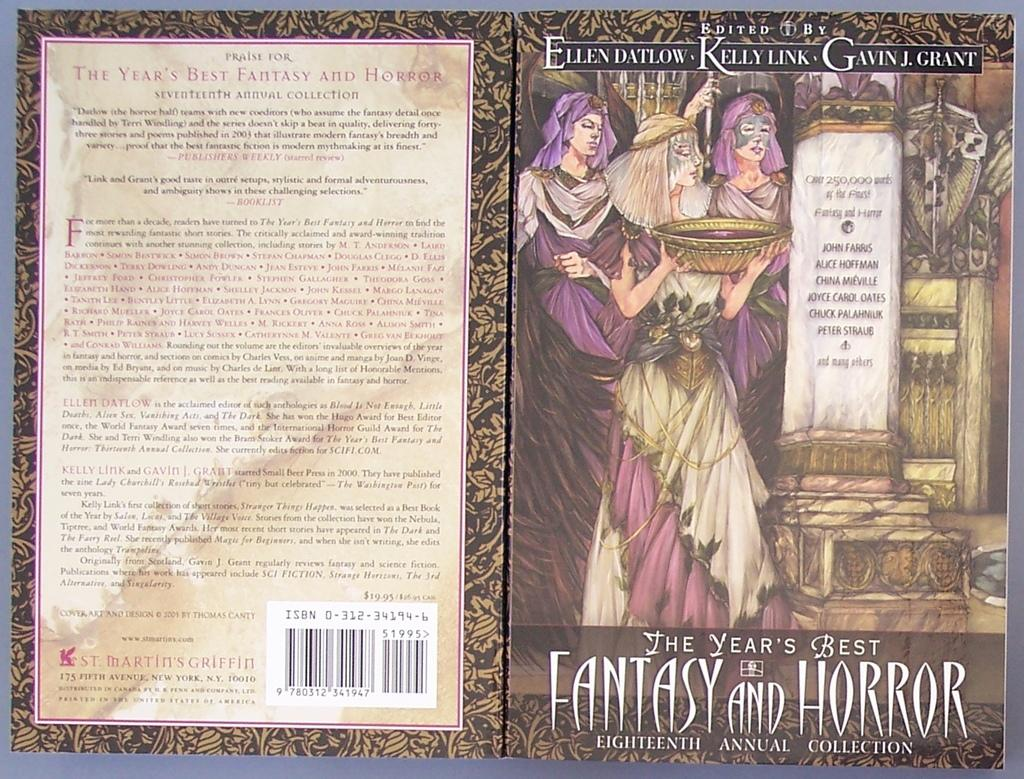<image>
Render a clear and concise summary of the photo. The front and back cover of a Fantasy and Horror book is shown simultaneously. 